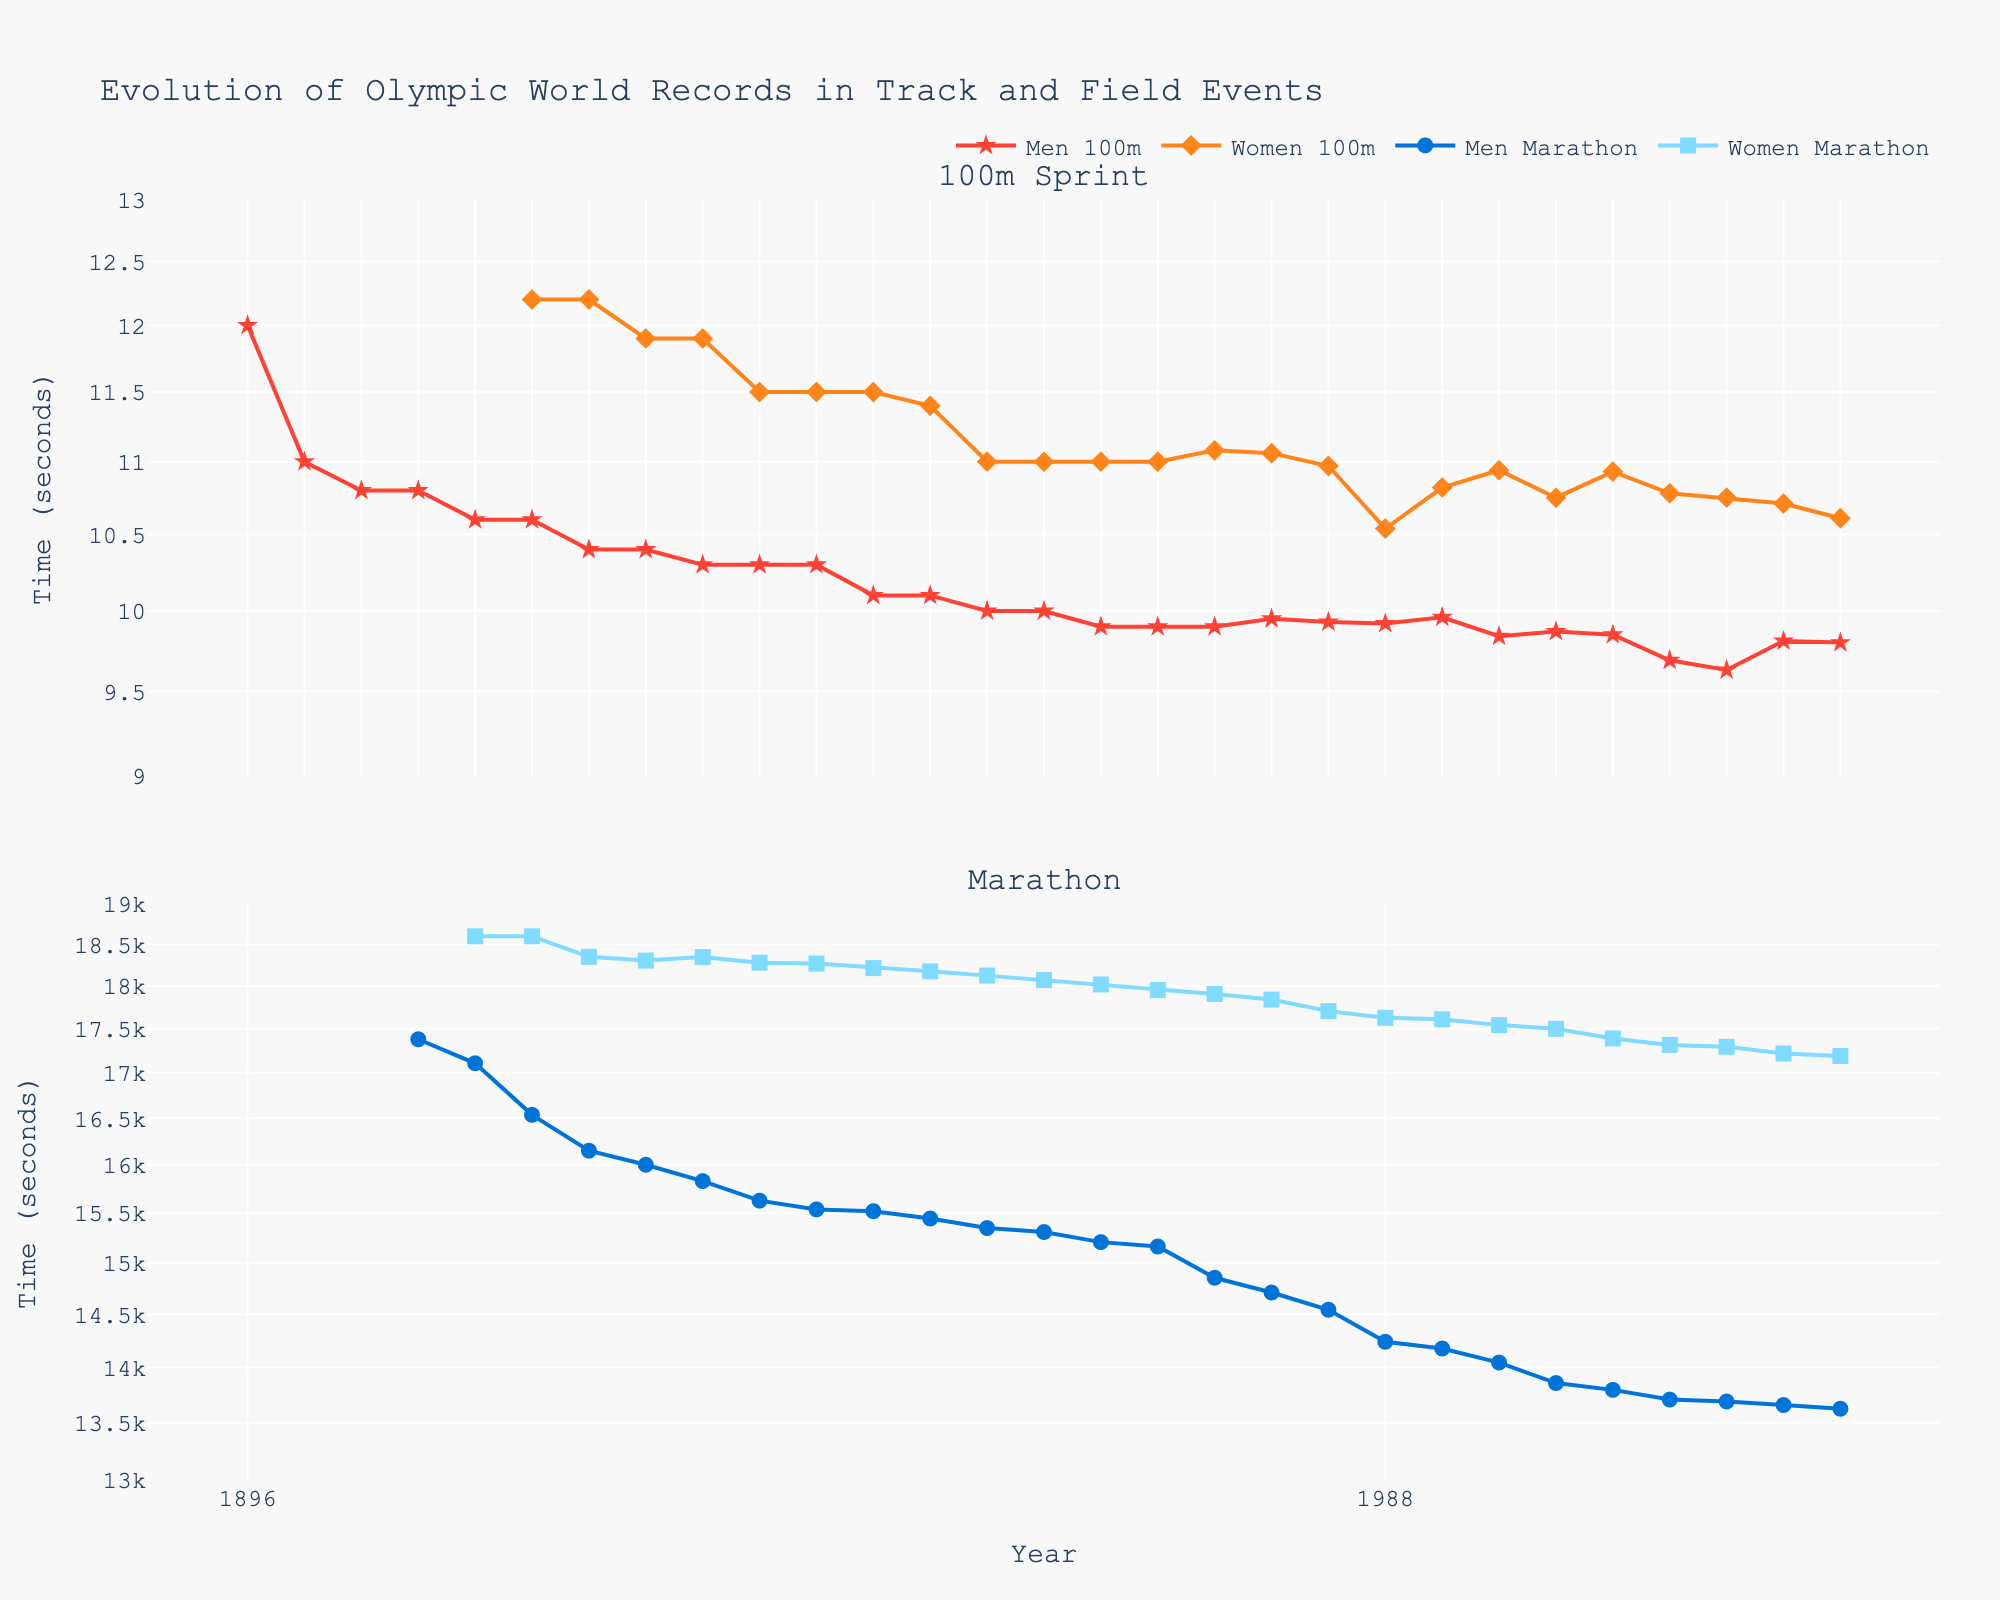How has the men's 100m Olympic world record changed from 1896 to 2020? The men's 100m Olympic world record has decreased over time, starting at 12 seconds in 1896 and reaching 9.80 seconds by 2020.
Answer: The records have improved from 12.0 to 9.80 seconds When did the women's 100m Olympic world record start being recorded in the figure, and what was the initial time? The women's 100m Olympic world record starts being recorded in 1920, with an initial record of 12.2 seconds.
Answer: 1920, 12.2 seconds How does the trend of marathon world records for men compare to the same trend for women between 1920 and 2020? Both men's and women's marathon world records show a consistent decrease over time, with men's times improving from about 16,536 seconds to 13,625 seconds and women's times from about 18,600 seconds to 17,189 seconds.
Answer: Both show consistent decreases Whats's the difference between men's and women's 100m records in 1988? To find the difference, look at the men's time (9.92 seconds) and the women's time (10.54 seconds), then subtract the two (10.54 - 9.92).
Answer: 0.62 seconds Which event showed a greater percentage decrease in world record times for men, 100m or marathon, from the beginning to the end of the dataset? For the 100m, the decrease is from 12.0 to 9.80 seconds (12.0 - 9.80 = 2.2 seconds). The percentage change is \( \frac{2.2}{12.0} \approx 18.3\% \). For the marathon, the decrease is from 17380.0 to 13625.0 seconds (17380.0 - 13625.0 = 3755 seconds). The percentage change is \( \frac{3755}{17380.0} \approx 21.6\% \).
Answer: Marathon, 21.6% Why is a log scale used for the y-axis in these plots? A log scale is often used for a wide range of values to make it easier to observe percentage changes and patterns in the data, and because the improvements in world records can be multiplicative rather than additive.
Answer: To observe percentage changes and patterns In which decade did the men’s 100m Olympic world record first drop below 10 seconds? The men's 100m world record first dropped below 10 seconds in the 1960s.
Answer: 1960s How much did the men’s marathon world record improve from 1908 to 2020? In 1908, the men's marathon world record was 17,380 seconds, and in 2020 it was 13,625 seconds. The improvement is 17,380 - 13,625 = 3,755 seconds.
Answer: 3,755 seconds How did the women’s marathon world record time change from 1932 to 1936? The women's marathon world record changed from 18,347.2 seconds in 1932 to 18,279.8 seconds in 1936, showing an improvement (decrease) of 67.4 seconds.
Answer: 67.4 seconds What is the color scheme used to denote men’s and women’s records in the 100m event? The color for men's 100m records is bright red, and for women’s 100m records it is orange.
Answer: Bright red and orange 